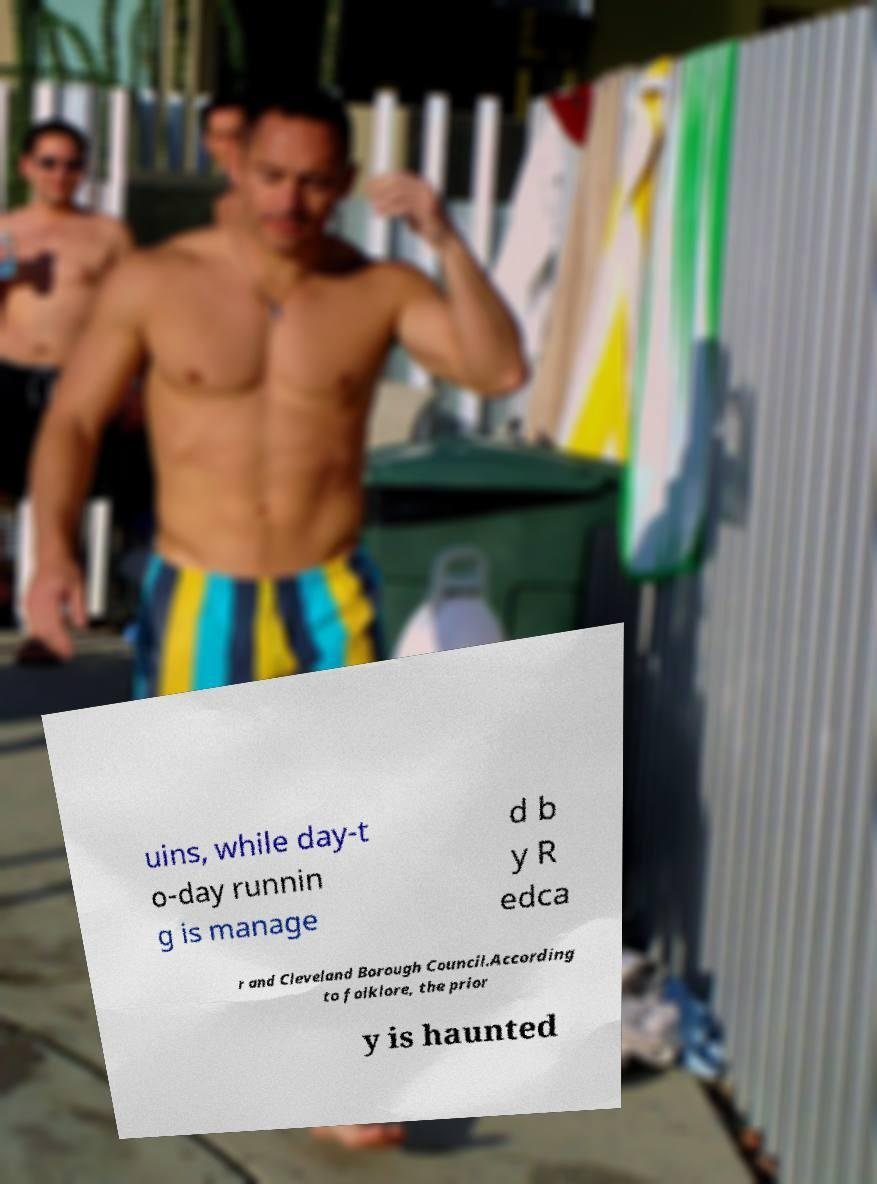Please read and relay the text visible in this image. What does it say? uins, while day-t o-day runnin g is manage d b y R edca r and Cleveland Borough Council.According to folklore, the prior y is haunted 